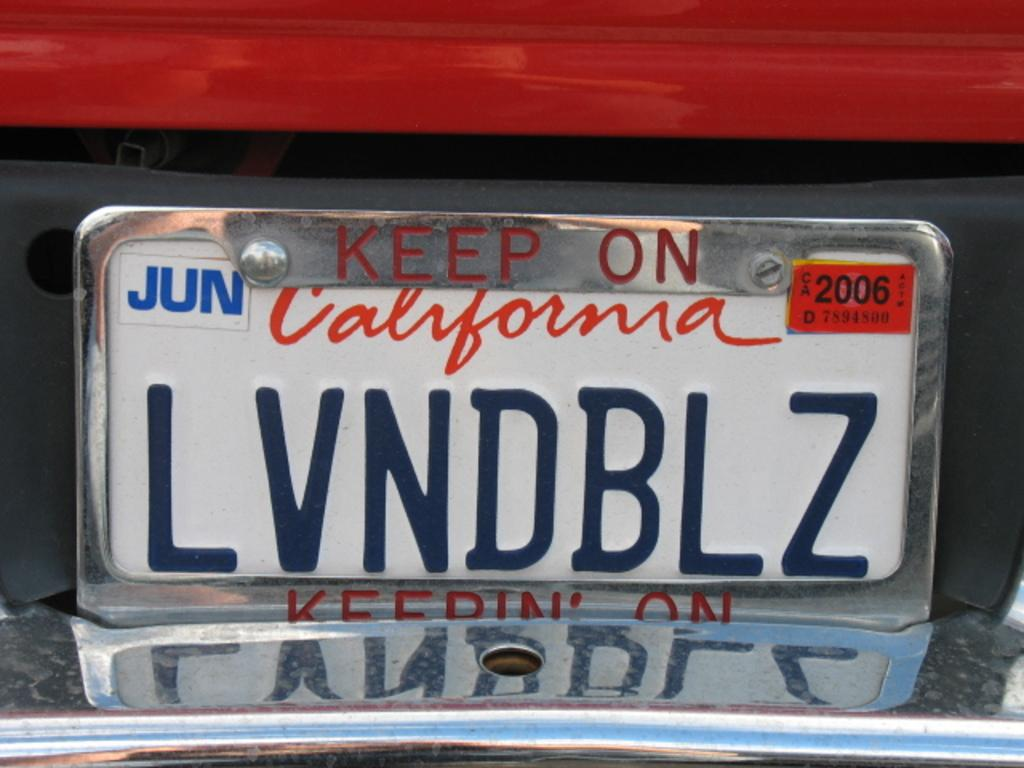<image>
Create a compact narrative representing the image presented. A closeup of California license plate number LVNDBL. 